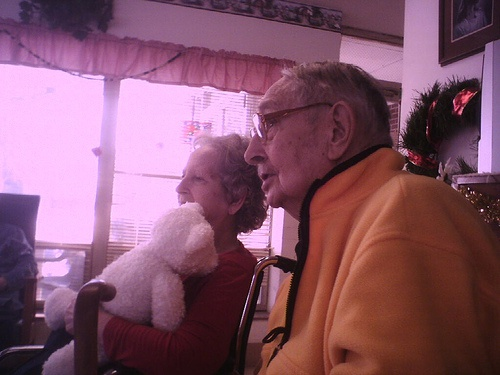Describe the objects in this image and their specific colors. I can see people in purple, maroon, black, and brown tones, people in purple, black, and maroon tones, teddy bear in purple and gray tones, chair in purple and black tones, and people in purple, black, and navy tones in this image. 